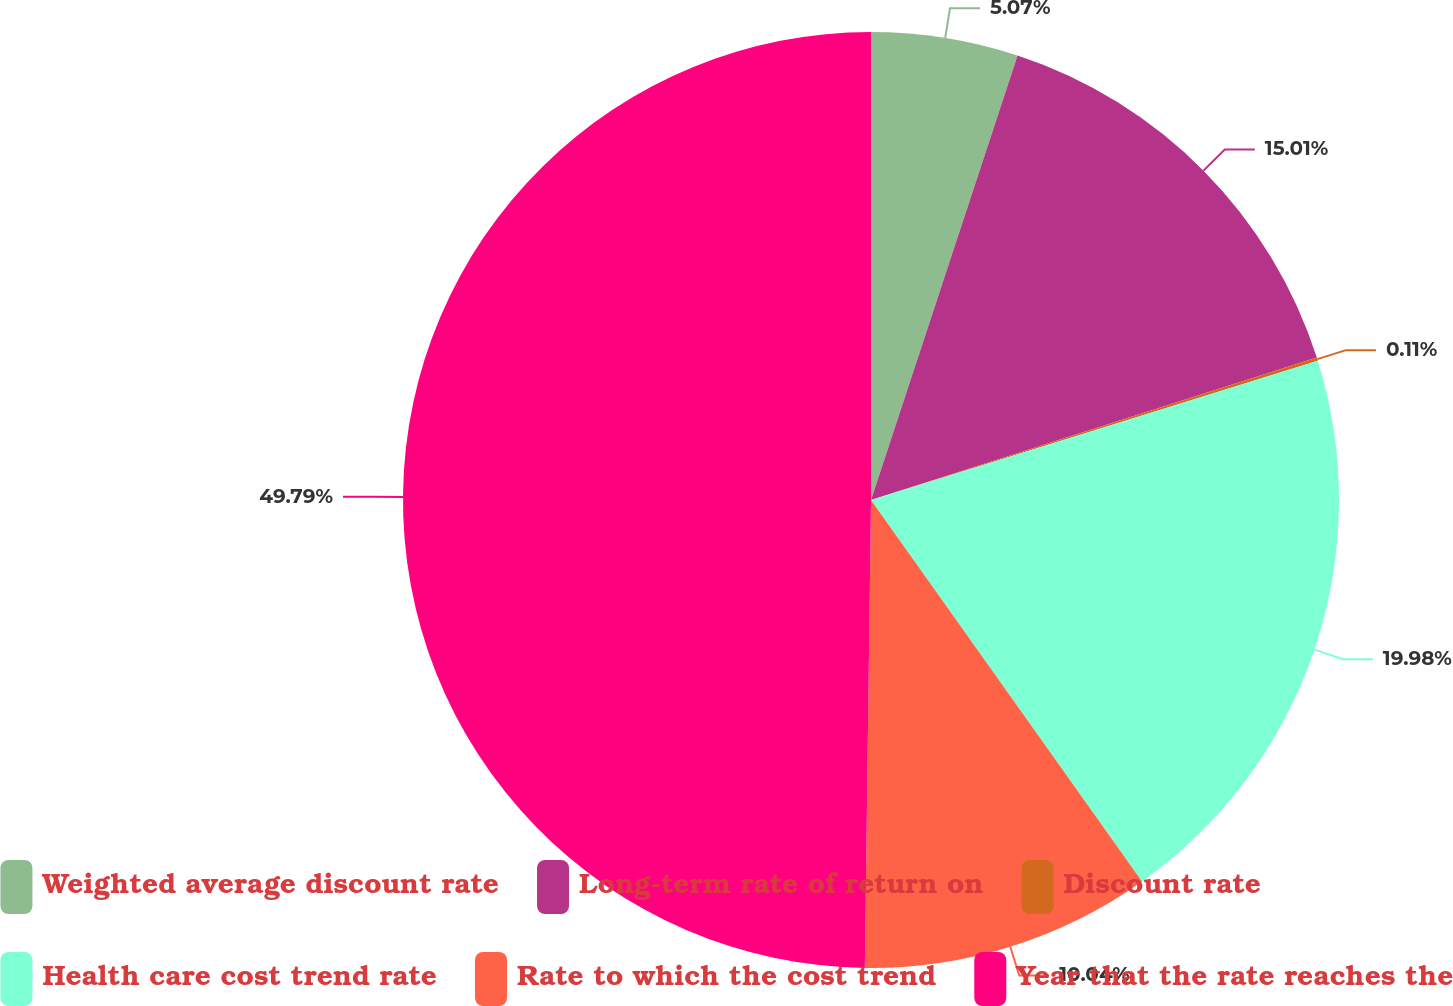Convert chart to OTSL. <chart><loc_0><loc_0><loc_500><loc_500><pie_chart><fcel>Weighted average discount rate<fcel>Long-term rate of return on<fcel>Discount rate<fcel>Health care cost trend rate<fcel>Rate to which the cost trend<fcel>Year that the rate reaches the<nl><fcel>5.07%<fcel>15.01%<fcel>0.11%<fcel>19.98%<fcel>10.04%<fcel>49.79%<nl></chart> 